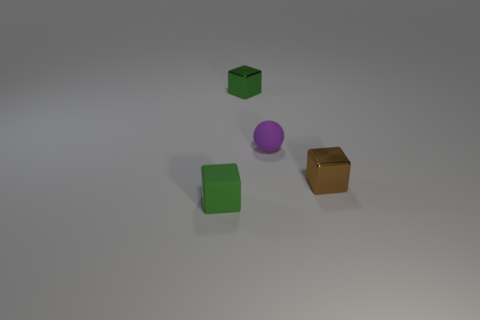Add 1 green blocks. How many objects exist? 5 Subtract all blocks. How many objects are left? 1 Add 3 metal objects. How many metal objects are left? 5 Add 3 purple things. How many purple things exist? 4 Subtract 0 purple cylinders. How many objects are left? 4 Subtract all small purple balls. Subtract all shiny objects. How many objects are left? 1 